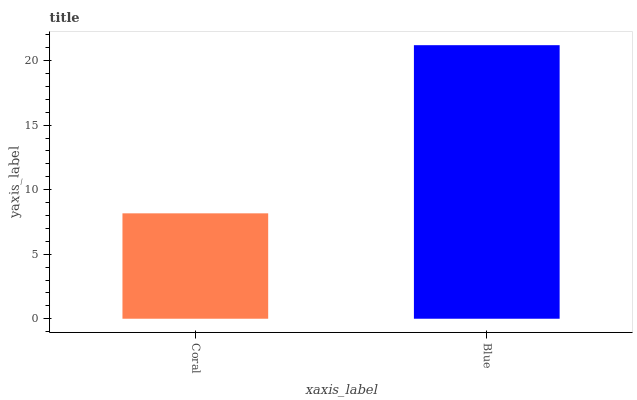Is Coral the minimum?
Answer yes or no. Yes. Is Blue the maximum?
Answer yes or no. Yes. Is Blue the minimum?
Answer yes or no. No. Is Blue greater than Coral?
Answer yes or no. Yes. Is Coral less than Blue?
Answer yes or no. Yes. Is Coral greater than Blue?
Answer yes or no. No. Is Blue less than Coral?
Answer yes or no. No. Is Blue the high median?
Answer yes or no. Yes. Is Coral the low median?
Answer yes or no. Yes. Is Coral the high median?
Answer yes or no. No. Is Blue the low median?
Answer yes or no. No. 